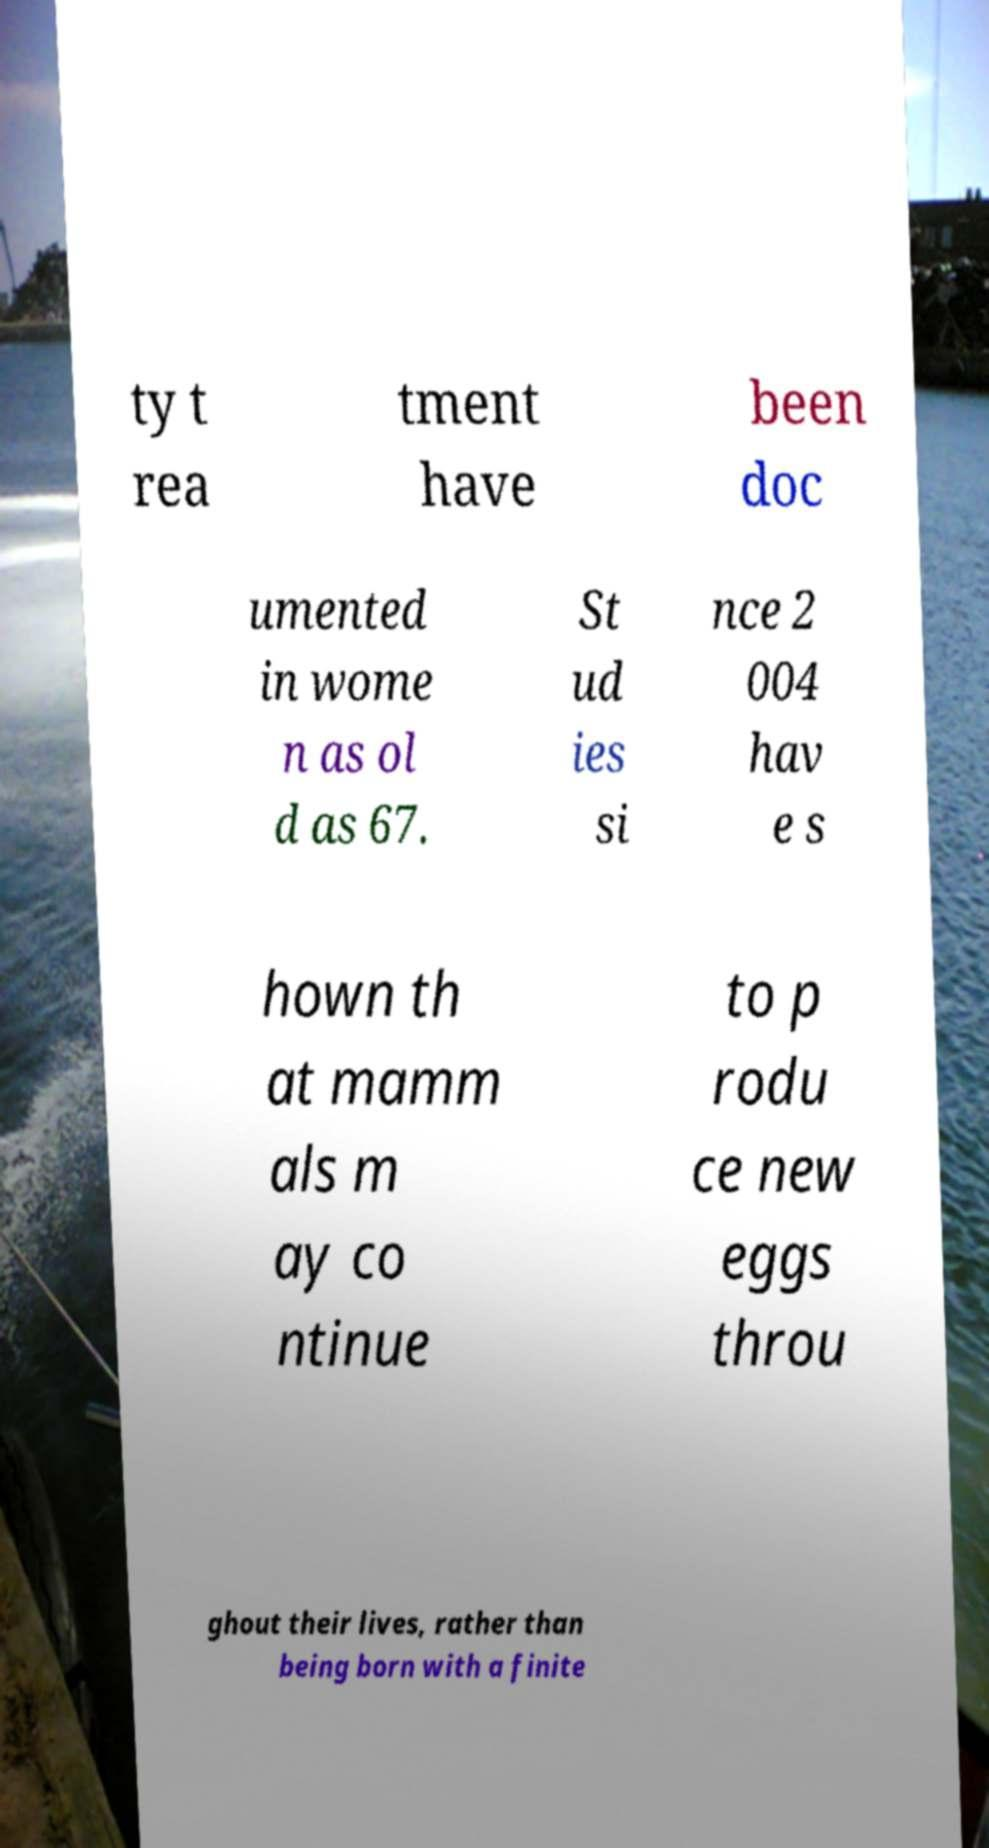Please read and relay the text visible in this image. What does it say? ty t rea tment have been doc umented in wome n as ol d as 67. St ud ies si nce 2 004 hav e s hown th at mamm als m ay co ntinue to p rodu ce new eggs throu ghout their lives, rather than being born with a finite 